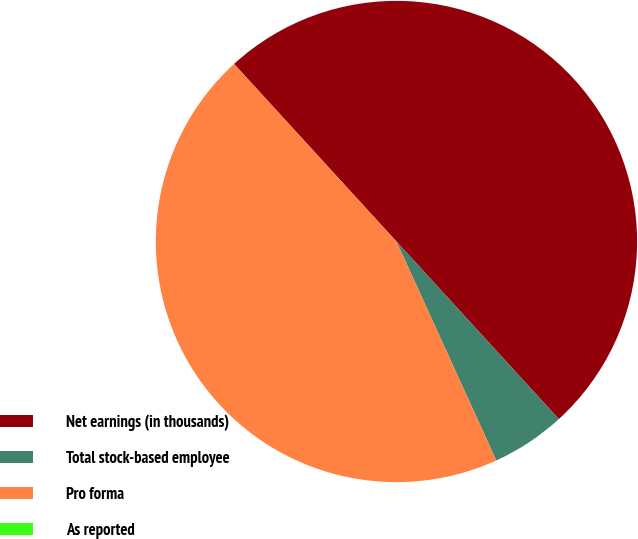<chart> <loc_0><loc_0><loc_500><loc_500><pie_chart><fcel>Net earnings (in thousands)<fcel>Total stock-based employee<fcel>Pro forma<fcel>As reported<nl><fcel>50.0%<fcel>4.98%<fcel>45.02%<fcel>0.0%<nl></chart> 